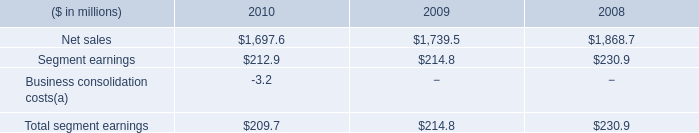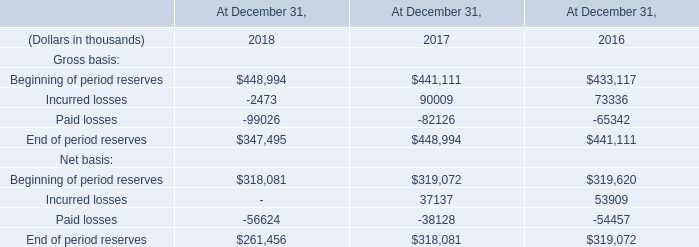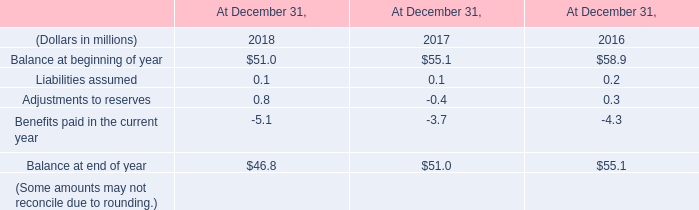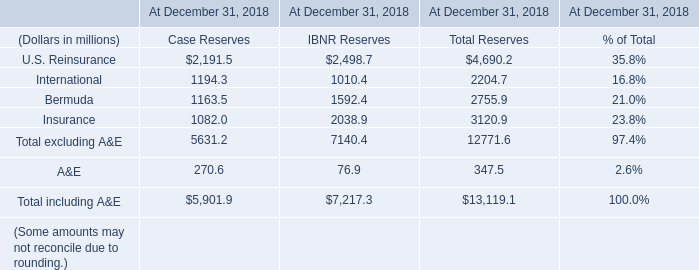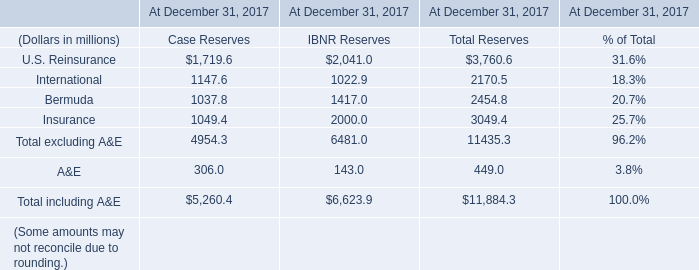In which section the sum of U.S. Reinsurance has the highest value? 
Answer: IBNR Reserves. 